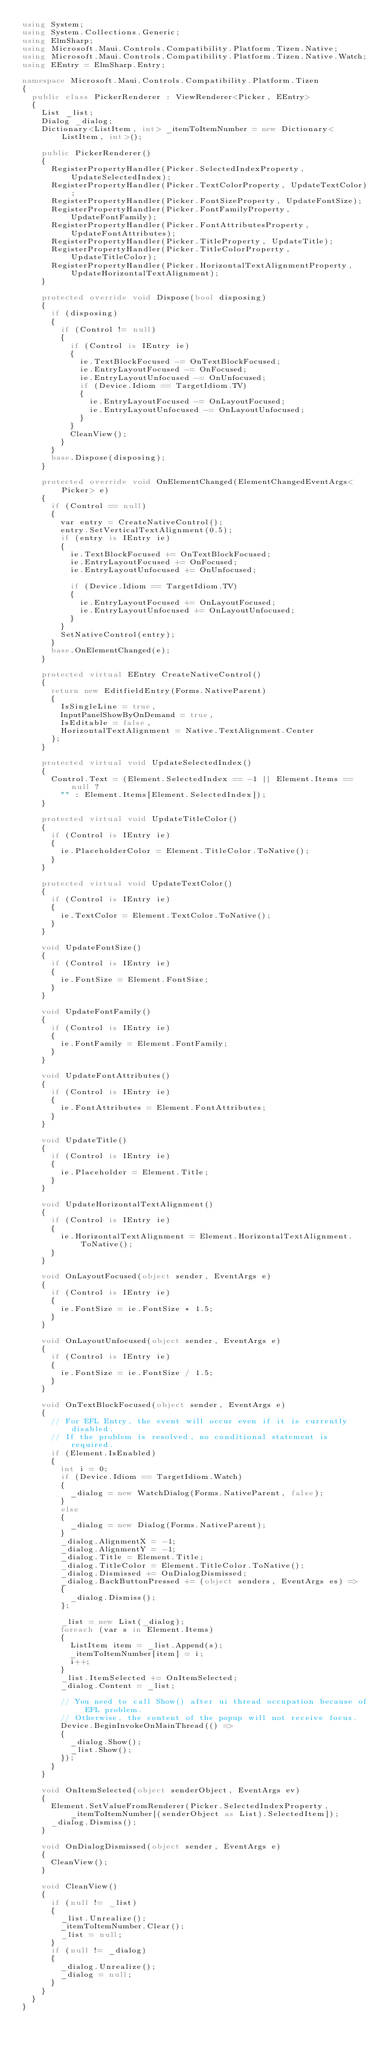<code> <loc_0><loc_0><loc_500><loc_500><_C#_>using System;
using System.Collections.Generic;
using ElmSharp;
using Microsoft.Maui.Controls.Compatibility.Platform.Tizen.Native;
using Microsoft.Maui.Controls.Compatibility.Platform.Tizen.Native.Watch;
using EEntry = ElmSharp.Entry;

namespace Microsoft.Maui.Controls.Compatibility.Platform.Tizen
{
	public class PickerRenderer : ViewRenderer<Picker, EEntry>
	{
		List _list;
		Dialog _dialog;
		Dictionary<ListItem, int> _itemToItemNumber = new Dictionary<ListItem, int>();

		public PickerRenderer()
		{
			RegisterPropertyHandler(Picker.SelectedIndexProperty, UpdateSelectedIndex);
			RegisterPropertyHandler(Picker.TextColorProperty, UpdateTextColor);
			RegisterPropertyHandler(Picker.FontSizeProperty, UpdateFontSize);
			RegisterPropertyHandler(Picker.FontFamilyProperty, UpdateFontFamily);
			RegisterPropertyHandler(Picker.FontAttributesProperty, UpdateFontAttributes);
			RegisterPropertyHandler(Picker.TitleProperty, UpdateTitle);
			RegisterPropertyHandler(Picker.TitleColorProperty, UpdateTitleColor);
			RegisterPropertyHandler(Picker.HorizontalTextAlignmentProperty, UpdateHorizontalTextAlignment);
		}

		protected override void Dispose(bool disposing)
		{
			if (disposing)
			{
				if (Control != null)
				{
					if (Control is IEntry ie)
					{
						ie.TextBlockFocused -= OnTextBlockFocused;
						ie.EntryLayoutFocused -= OnFocused;
						ie.EntryLayoutUnfocused -= OnUnfocused;
						if (Device.Idiom == TargetIdiom.TV)
						{
							ie.EntryLayoutFocused -= OnLayoutFocused;
							ie.EntryLayoutUnfocused -= OnLayoutUnfocused;
						}
					}
					CleanView();
				}
			}
			base.Dispose(disposing);
		}

		protected override void OnElementChanged(ElementChangedEventArgs<Picker> e)
		{
			if (Control == null)
			{
				var entry = CreateNativeControl();
				entry.SetVerticalTextAlignment(0.5);
				if (entry is IEntry ie)
				{
					ie.TextBlockFocused += OnTextBlockFocused;
					ie.EntryLayoutFocused += OnFocused;
					ie.EntryLayoutUnfocused += OnUnfocused;

					if (Device.Idiom == TargetIdiom.TV)
					{
						ie.EntryLayoutFocused += OnLayoutFocused;
						ie.EntryLayoutUnfocused += OnLayoutUnfocused;
					}
				}
				SetNativeControl(entry);
			}
			base.OnElementChanged(e);
		}

		protected virtual EEntry CreateNativeControl()
		{
			return new EditfieldEntry(Forms.NativeParent)
			{
				IsSingleLine = true,
				InputPanelShowByOnDemand = true,
				IsEditable = false,
				HorizontalTextAlignment = Native.TextAlignment.Center
			};
		}

		protected virtual void UpdateSelectedIndex()
		{
			Control.Text = (Element.SelectedIndex == -1 || Element.Items == null ?
				"" : Element.Items[Element.SelectedIndex]);
		}

		protected virtual void UpdateTitleColor()
		{
			if (Control is IEntry ie)
			{
				ie.PlaceholderColor = Element.TitleColor.ToNative();
			}
		}

		protected virtual void UpdateTextColor()
		{
			if (Control is IEntry ie)
			{
				ie.TextColor = Element.TextColor.ToNative();
			}
		}

		void UpdateFontSize()
		{
			if (Control is IEntry ie)
			{
				ie.FontSize = Element.FontSize;
			}
		}

		void UpdateFontFamily()
		{
			if (Control is IEntry ie)
			{
				ie.FontFamily = Element.FontFamily;
			}
		}

		void UpdateFontAttributes()
		{
			if (Control is IEntry ie)
			{
				ie.FontAttributes = Element.FontAttributes;
			}
		}

		void UpdateTitle()
		{
			if (Control is IEntry ie)
			{
				ie.Placeholder = Element.Title;
			}
		}

		void UpdateHorizontalTextAlignment()
		{
			if (Control is IEntry ie)
			{
				ie.HorizontalTextAlignment = Element.HorizontalTextAlignment.ToNative();
			}
		}

		void OnLayoutFocused(object sender, EventArgs e)
		{
			if (Control is IEntry ie)
			{
				ie.FontSize = ie.FontSize * 1.5;
			}
		}

		void OnLayoutUnfocused(object sender, EventArgs e)
		{
			if (Control is IEntry ie)
			{
				ie.FontSize = ie.FontSize / 1.5;
			}
		}

		void OnTextBlockFocused(object sender, EventArgs e)
		{
			// For EFL Entry, the event will occur even if it is currently disabled.
			// If the problem is resolved, no conditional statement is required.
			if (Element.IsEnabled)
			{
				int i = 0;
				if (Device.Idiom == TargetIdiom.Watch)
				{
					_dialog = new WatchDialog(Forms.NativeParent, false);
				}
				else
				{
					_dialog = new Dialog(Forms.NativeParent);
				}
				_dialog.AlignmentX = -1;
				_dialog.AlignmentY = -1;
				_dialog.Title = Element.Title;
				_dialog.TitleColor = Element.TitleColor.ToNative();
				_dialog.Dismissed += OnDialogDismissed;
				_dialog.BackButtonPressed += (object senders, EventArgs es) =>
				{
					_dialog.Dismiss();
				};

				_list = new List(_dialog);
				foreach (var s in Element.Items)
				{
					ListItem item = _list.Append(s);
					_itemToItemNumber[item] = i;
					i++;
				}
				_list.ItemSelected += OnItemSelected;
				_dialog.Content = _list;

				// You need to call Show() after ui thread occupation because of EFL problem.
				// Otherwise, the content of the popup will not receive focus.
				Device.BeginInvokeOnMainThread(() =>
				{
					_dialog.Show();
					_list.Show();
				});
			}
		}

		void OnItemSelected(object senderObject, EventArgs ev)
		{
			Element.SetValueFromRenderer(Picker.SelectedIndexProperty, _itemToItemNumber[(senderObject as List).SelectedItem]);
			_dialog.Dismiss();
		}

		void OnDialogDismissed(object sender, EventArgs e)
		{
			CleanView();
		}

		void CleanView()
		{
			if (null != _list)
			{
				_list.Unrealize();
				_itemToItemNumber.Clear();
				_list = null;
			}
			if (null != _dialog)
			{
				_dialog.Unrealize();
				_dialog = null;
			}
		}
	}
}
</code> 